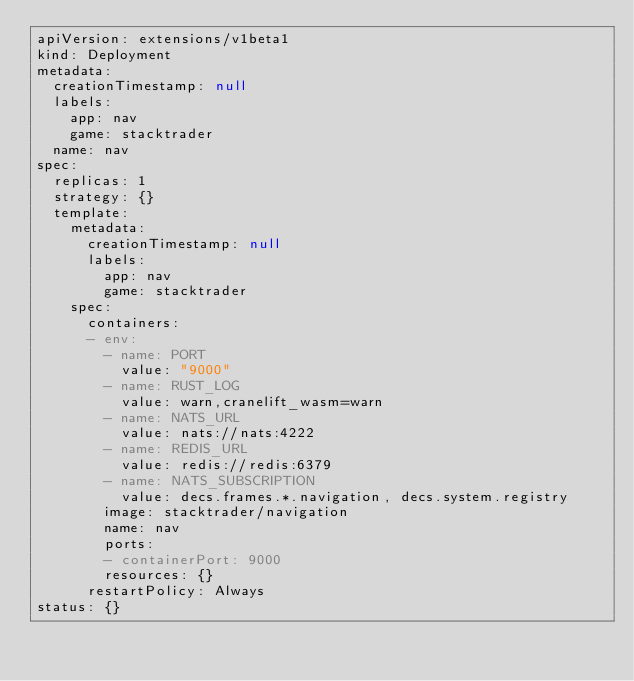Convert code to text. <code><loc_0><loc_0><loc_500><loc_500><_YAML_>apiVersion: extensions/v1beta1
kind: Deployment
metadata:
  creationTimestamp: null
  labels:
    app: nav
    game: stacktrader
  name: nav
spec:
  replicas: 1
  strategy: {}
  template:
    metadata:
      creationTimestamp: null
      labels:
        app: nav
        game: stacktrader
    spec:
      containers:
      - env:
        - name: PORT
          value: "9000"
        - name: RUST_LOG
          value: warn,cranelift_wasm=warn
        - name: NATS_URL
          value: nats://nats:4222
        - name: REDIS_URL
          value: redis://redis:6379
        - name: NATS_SUBSCRIPTION
          value: decs.frames.*.navigation, decs.system.registry
        image: stacktrader/navigation
        name: nav
        ports:
        - containerPort: 9000
        resources: {}
      restartPolicy: Always
status: {}
</code> 